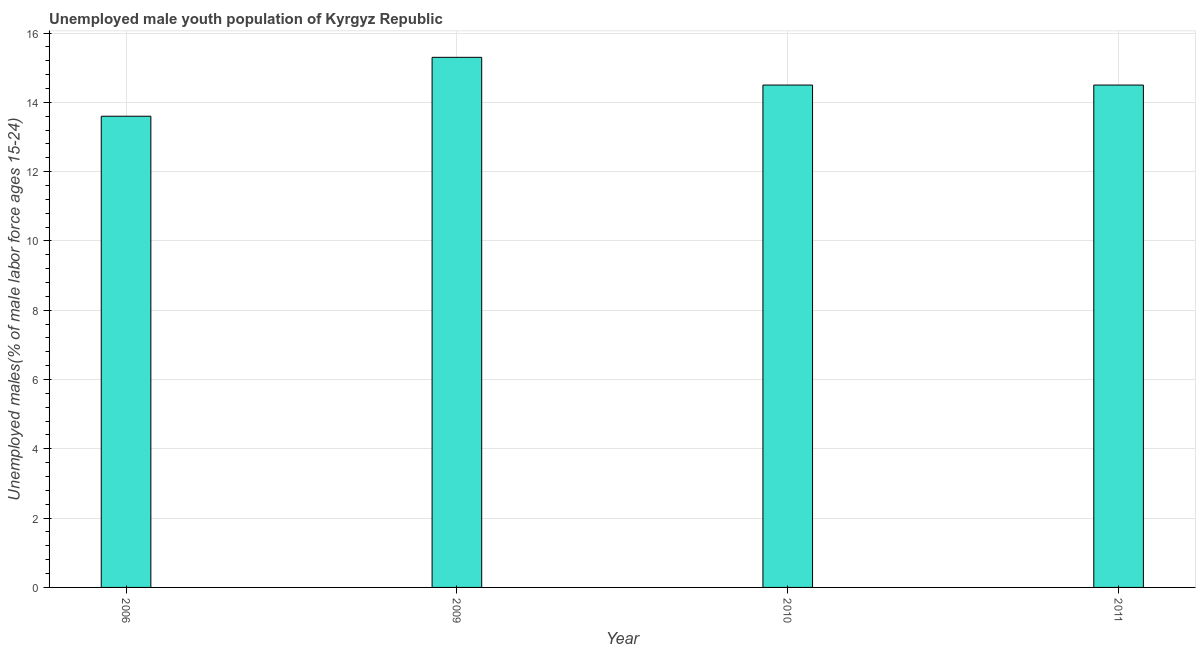Does the graph contain grids?
Offer a terse response. Yes. What is the title of the graph?
Your answer should be very brief. Unemployed male youth population of Kyrgyz Republic. What is the label or title of the X-axis?
Your answer should be compact. Year. What is the label or title of the Y-axis?
Your answer should be very brief. Unemployed males(% of male labor force ages 15-24). What is the unemployed male youth in 2006?
Give a very brief answer. 13.6. Across all years, what is the maximum unemployed male youth?
Keep it short and to the point. 15.3. Across all years, what is the minimum unemployed male youth?
Provide a short and direct response. 13.6. In which year was the unemployed male youth minimum?
Ensure brevity in your answer.  2006. What is the sum of the unemployed male youth?
Your answer should be compact. 57.9. What is the difference between the unemployed male youth in 2006 and 2011?
Keep it short and to the point. -0.9. What is the average unemployed male youth per year?
Your answer should be very brief. 14.47. Do a majority of the years between 2011 and 2010 (inclusive) have unemployed male youth greater than 13.6 %?
Ensure brevity in your answer.  No. What is the ratio of the unemployed male youth in 2006 to that in 2010?
Your answer should be very brief. 0.94. Is the sum of the unemployed male youth in 2009 and 2010 greater than the maximum unemployed male youth across all years?
Keep it short and to the point. Yes. What is the difference between the highest and the lowest unemployed male youth?
Provide a short and direct response. 1.7. In how many years, is the unemployed male youth greater than the average unemployed male youth taken over all years?
Provide a short and direct response. 3. How many bars are there?
Your answer should be very brief. 4. What is the difference between two consecutive major ticks on the Y-axis?
Make the answer very short. 2. What is the Unemployed males(% of male labor force ages 15-24) in 2006?
Offer a very short reply. 13.6. What is the Unemployed males(% of male labor force ages 15-24) of 2009?
Your answer should be very brief. 15.3. What is the Unemployed males(% of male labor force ages 15-24) in 2010?
Your answer should be very brief. 14.5. What is the difference between the Unemployed males(% of male labor force ages 15-24) in 2006 and 2011?
Your answer should be very brief. -0.9. What is the difference between the Unemployed males(% of male labor force ages 15-24) in 2009 and 2010?
Make the answer very short. 0.8. What is the difference between the Unemployed males(% of male labor force ages 15-24) in 2009 and 2011?
Provide a short and direct response. 0.8. What is the difference between the Unemployed males(% of male labor force ages 15-24) in 2010 and 2011?
Offer a very short reply. 0. What is the ratio of the Unemployed males(% of male labor force ages 15-24) in 2006 to that in 2009?
Ensure brevity in your answer.  0.89. What is the ratio of the Unemployed males(% of male labor force ages 15-24) in 2006 to that in 2010?
Provide a short and direct response. 0.94. What is the ratio of the Unemployed males(% of male labor force ages 15-24) in 2006 to that in 2011?
Your answer should be compact. 0.94. What is the ratio of the Unemployed males(% of male labor force ages 15-24) in 2009 to that in 2010?
Your answer should be compact. 1.05. What is the ratio of the Unemployed males(% of male labor force ages 15-24) in 2009 to that in 2011?
Provide a succinct answer. 1.05. What is the ratio of the Unemployed males(% of male labor force ages 15-24) in 2010 to that in 2011?
Give a very brief answer. 1. 